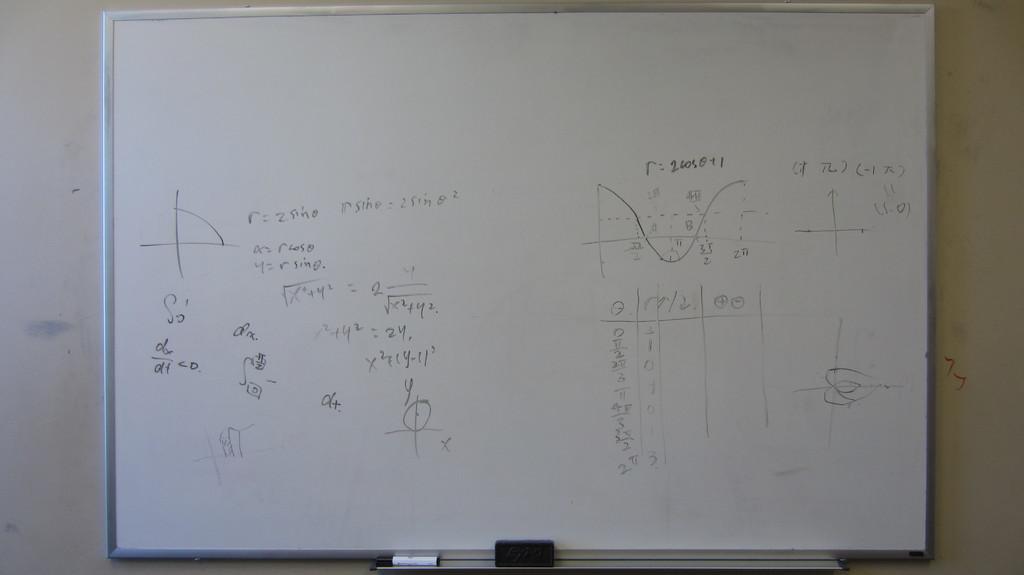What is the answer to r?
Your answer should be compact. 26050+1. Is there a graph on the board?
Your response must be concise. Yes. 